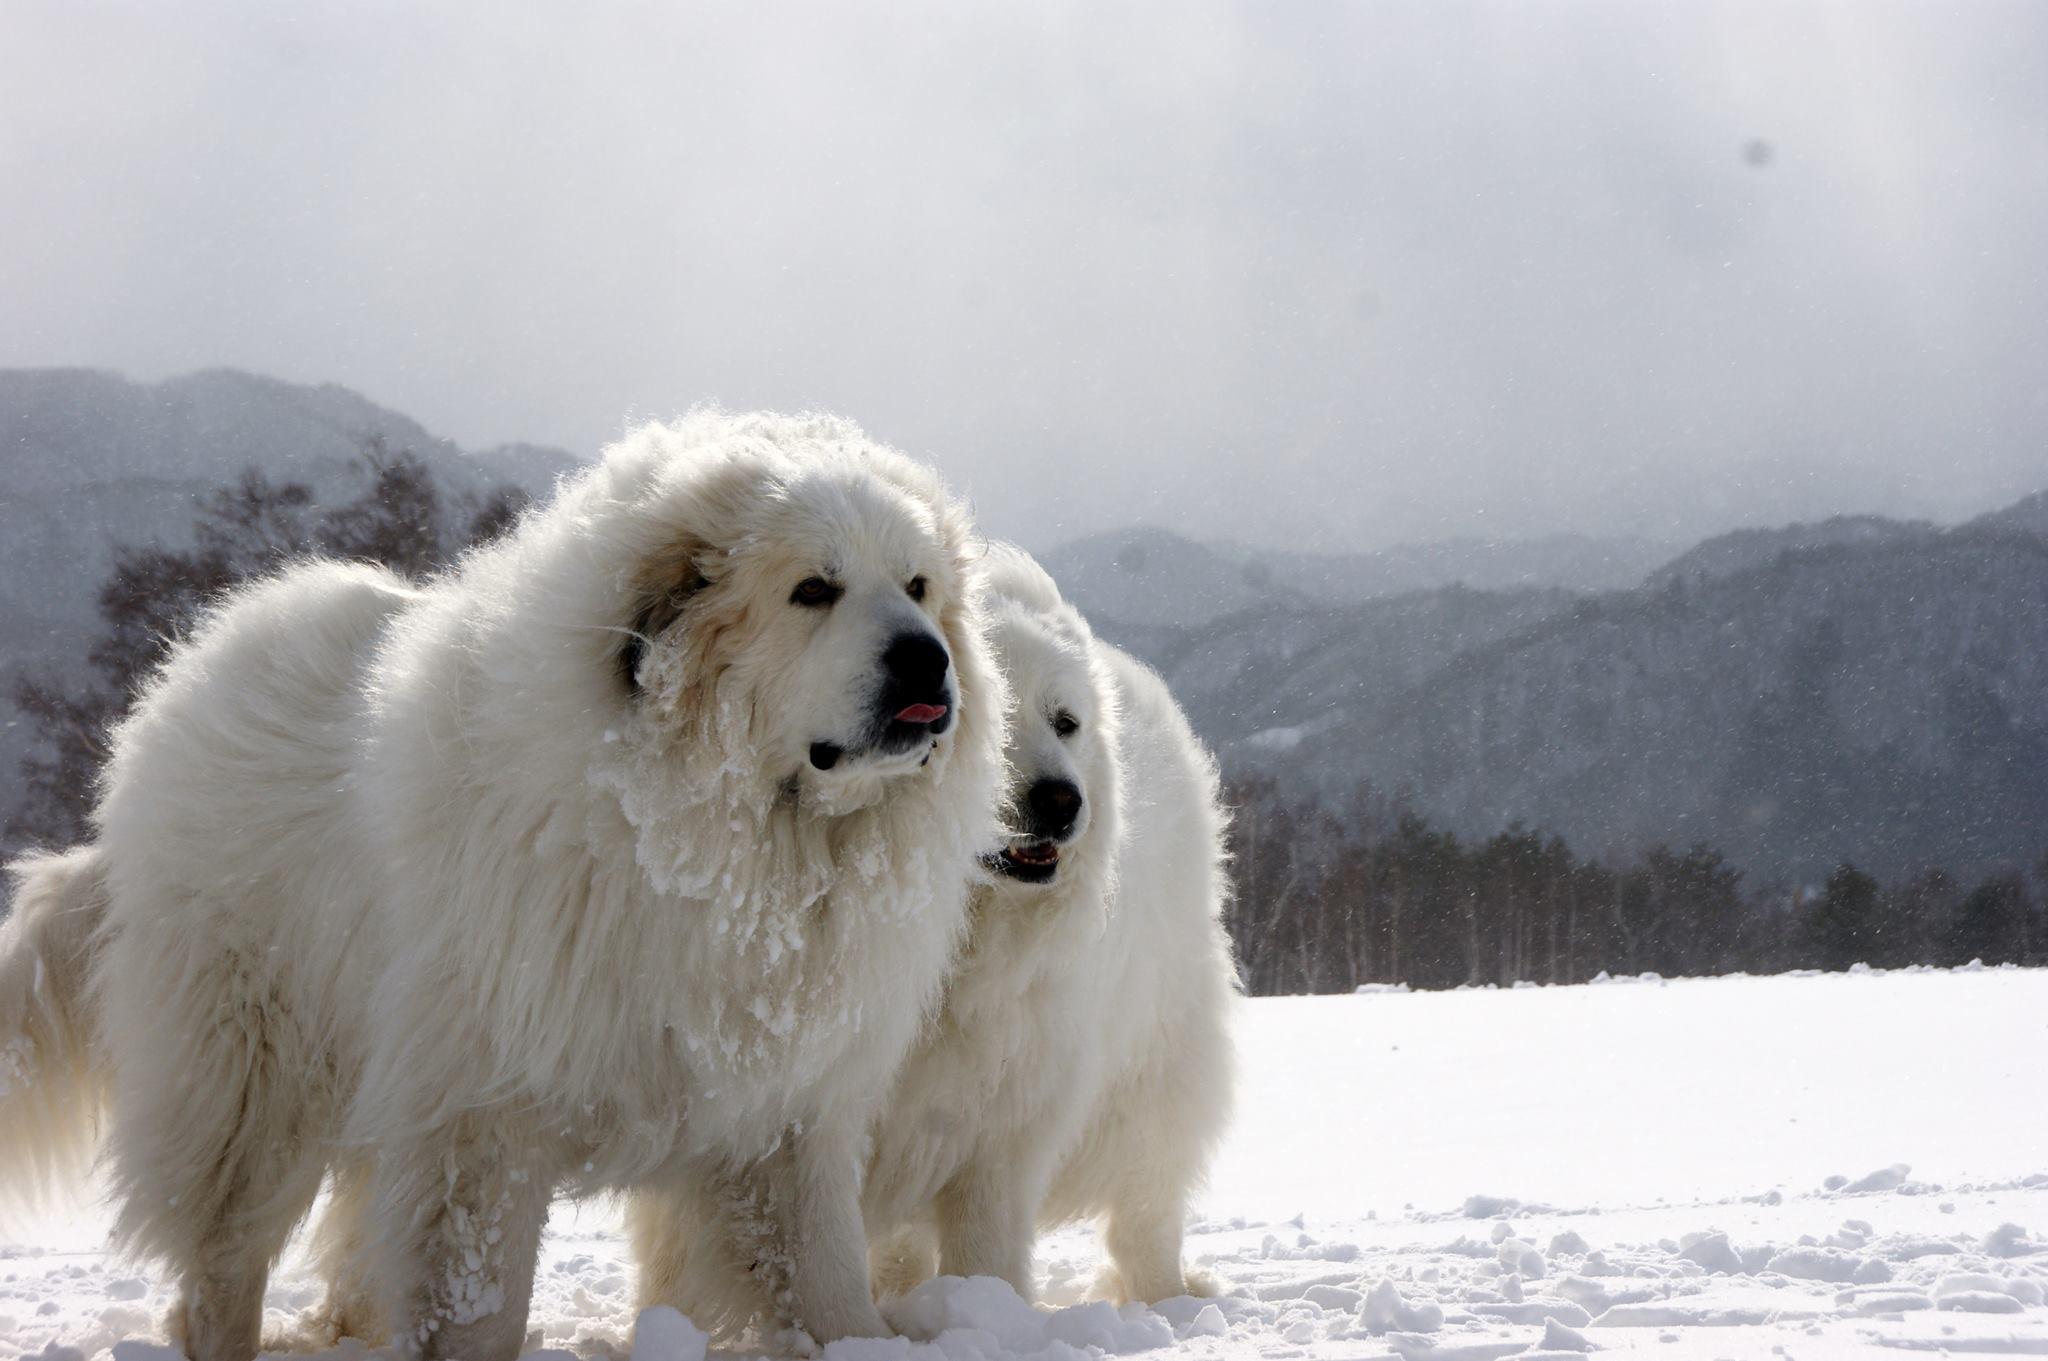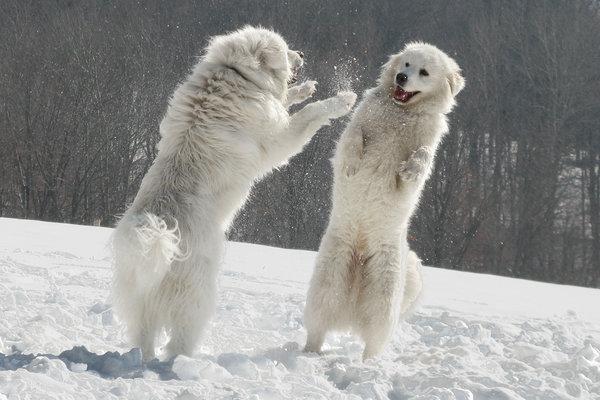The first image is the image on the left, the second image is the image on the right. Analyze the images presented: Is the assertion "There are three dogs in total." valid? Answer yes or no. No. 